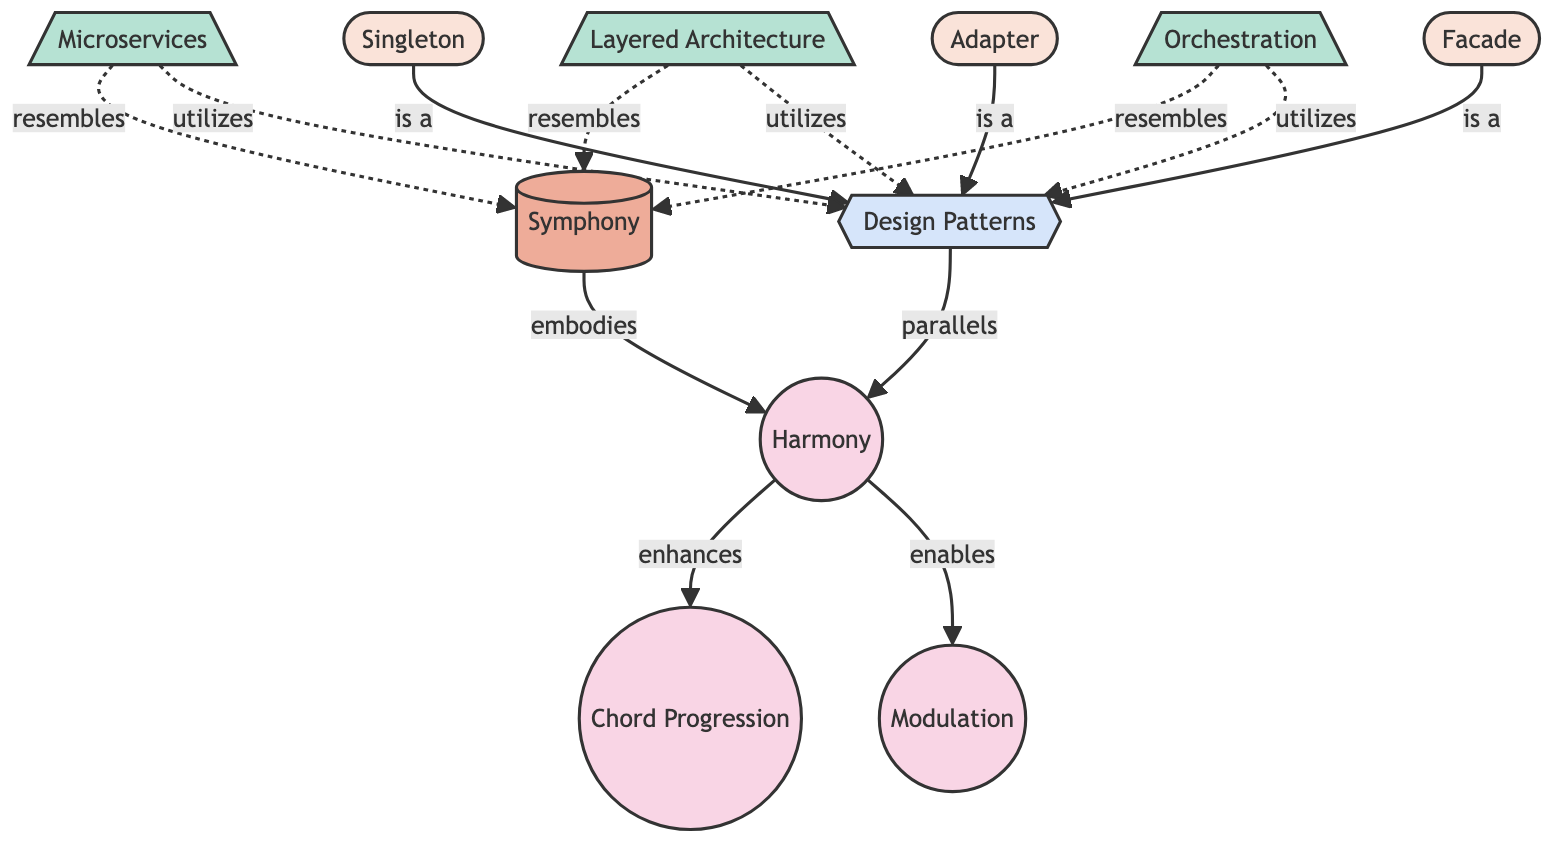What's the total number of nodes in the diagram? By counting all the distinct nodes presented, I can see there are 10 nodes listed: Harmony, Chord Progression, Modulation, Symphony, Microservices, Layered Architecture, Orchestration, Design Patterns, Singleton, Adapter, and Facade.
Answer: 10 What relationship exists between Harmony and Chord Progression? The relationship shown in the diagram indicates that Harmony enhances Chord Progression. This can be found directly in the edge connecting these two concepts.
Answer: enhances Which node embodies Harmony? According to the diagram, the node that embodies Harmony is Symphony. This is specified by the edge that points from Symphony to Harmony.
Answer: Symphony How many design patterns are mentioned in the diagram? There are three design patterns listed: Singleton, Adapter, and Facade. I count these from the second set of nodes that are categorized under Design Patterns.
Answer: 3 Which architecture pattern resembles Symphony? The diagram shows three architecture patterns that resemble Symphony: Microservices, Layered Architecture, and Orchestration. The relationships supporting this are represented with dashed edges leading to Symphony.
Answer: Microservices, Layered Architecture, Orchestration What action does Modulation have in relation to Harmony? The diagram states that Modulation enables Harmony, indicated by the direct edge connecting Modulation to Harmony.
Answer: enables Which design pattern is utilized by Microservices? The diagram shows that Microservices utilizes Design Patterns. This connection is represented by an edge leading from Microservices to Design Patterns.
Answer: Design Patterns What type of relationship is depicted between Orchestration and Design Patterns? The diagram illustrates that Orchestration utilizes Design Patterns, as represented by a directed edge leading from Orchestration to Design Patterns.
Answer: utilizes What is the main theme connecting classical music to software system architecture? The main theme connecting classical music to software system architecture, as depicted in this network, is how those music concepts, such as Harmony and Symphony, resemble architectural patterns like Microservices, Layered Architecture, and Orchestration, while also paralleling design patterns.
Answer: resemblance 